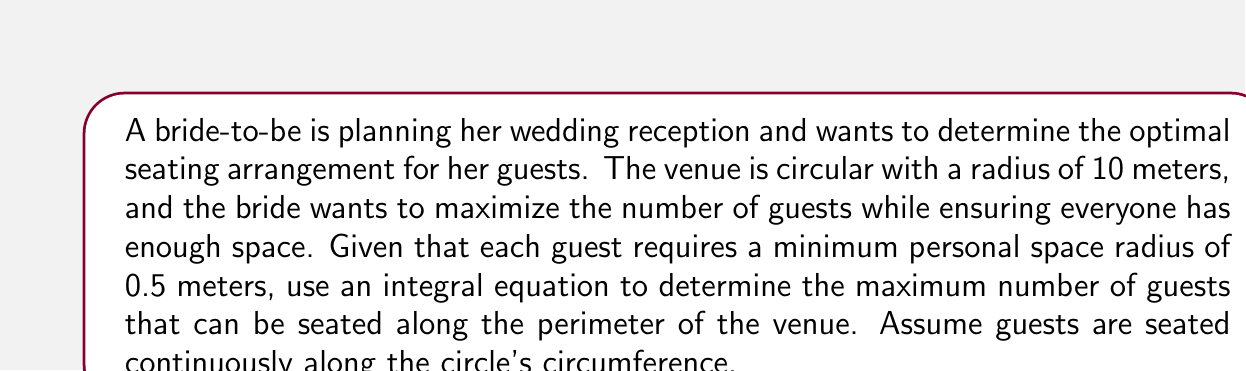What is the answer to this math problem? Let's approach this step-by-step:

1) The circumference of the circular venue is given by $C = 2\pi r$, where $r$ is the radius.
   $C = 2\pi(10) = 20\pi$ meters

2) Let $\theta$ represent the angle subtended at the center by each guest. The arc length occupied by each guest is $0.5 * 2 = 1$ meter (diameter of personal space).

3) We can set up the integral equation:

   $$\int_0^{2\pi} \frac{1}{2\pi} d\theta = 1$$

   This equation represents that the sum of all guest spaces should equal the full circumference.

4) Solving for the maximum number of guests, $n$:

   $$\frac{n}{2\pi} \int_0^{2\pi} d\theta = 1$$
   $$n \cdot 1 = 1$$
   $$n = 1$$

5) This means that one "guest unit" occupies $2\pi$ radians or the full circumference.

6) To find the actual number of guests, we divide the total circumference by the space each guest occupies:

   $$\text{Number of guests} = \frac{20\pi}{1} = 20\pi \approx 62.83$$

7) Since we can't have a fractional guest, we round down to the nearest whole number.
Answer: 62 guests 